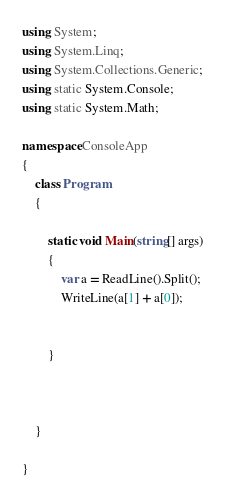Convert code to text. <code><loc_0><loc_0><loc_500><loc_500><_C#_>using System;
using System.Linq;
using System.Collections.Generic;
using static System.Console;
using static System.Math;

namespace ConsoleApp
{
    class Program
    {
        
        static void Main(string[] args)
        {
            var a = ReadLine().Split();
            WriteLine(a[1] + a[0]);


        }

       

    }

}
</code> 